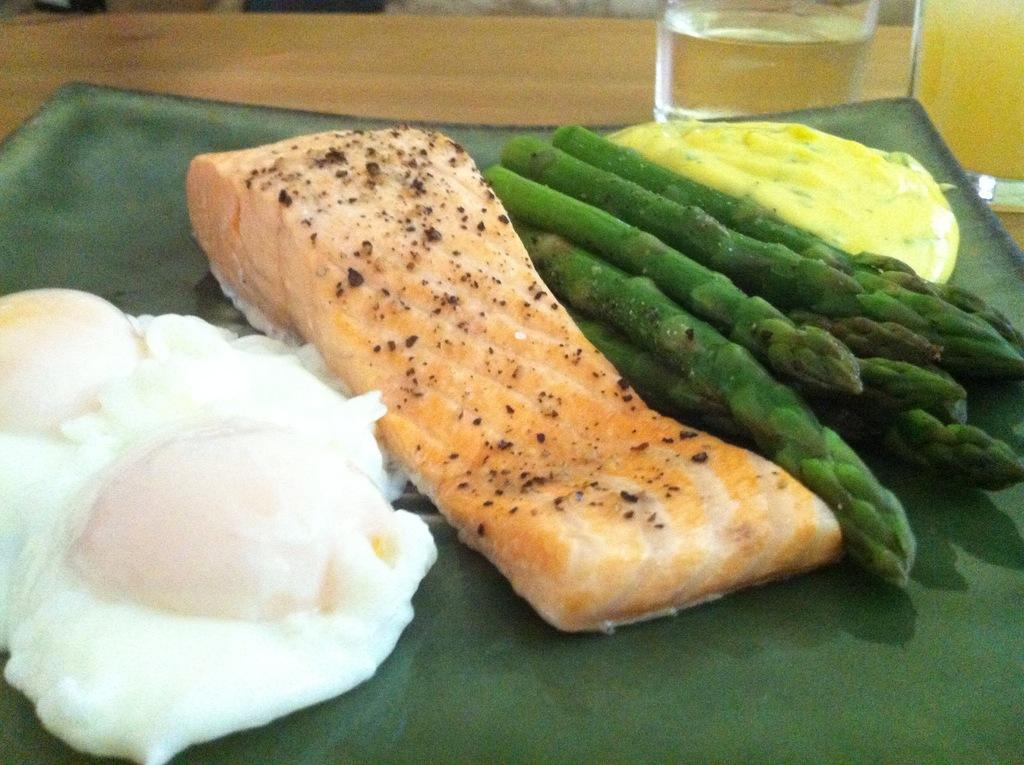What is on the plate that is visible in the image? The plate contains asparagus and meat, as well as other food items. What is the plate placed on in the image? The plate is on a wooden object. Are there any beverages visible in the image? Yes, there are two glasses with liquids in the top right corner of the image. How many lizards are crawling under the veil in the image? There are no lizards or veils present in the image. 